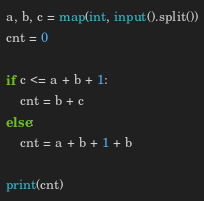<code> <loc_0><loc_0><loc_500><loc_500><_Python_>a, b, c = map(int, input().split())
cnt = 0

if c <= a + b + 1:
	cnt = b + c
else:
	cnt = a + b + 1 + b

print(cnt)</code> 